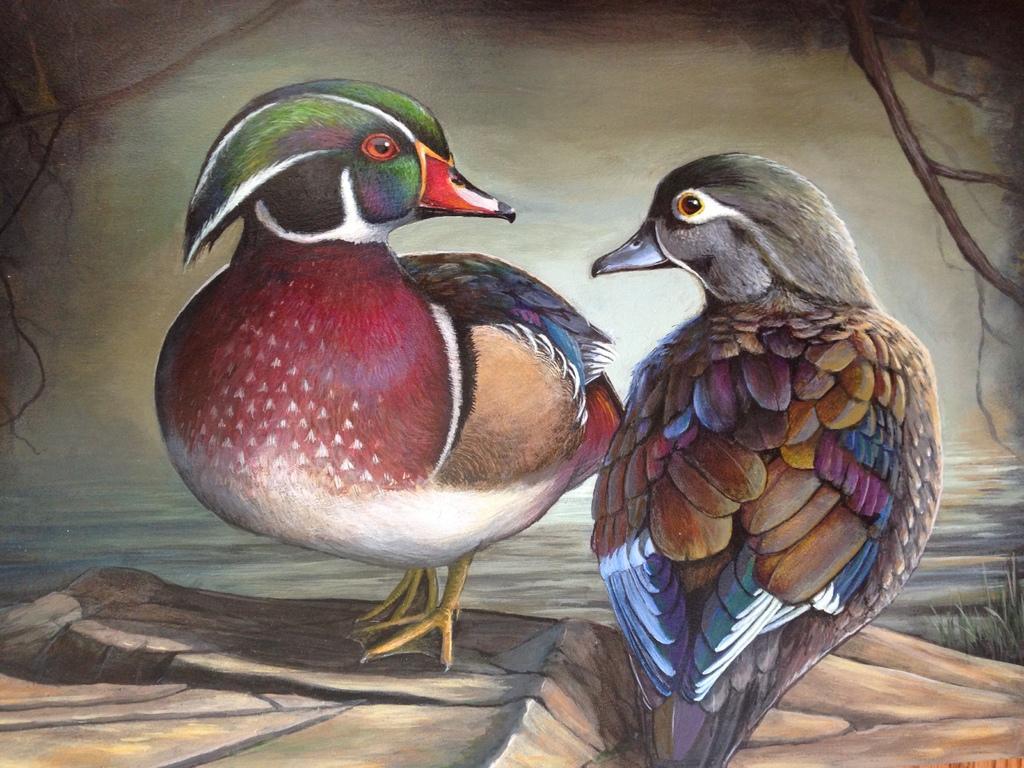Could you give a brief overview of what you see in this image? This is the picture of the painting. In this picture, we see two birds. They are in brown, red and green color. The bird on the left side is having a red color beak. In the background, we see trees and water. 